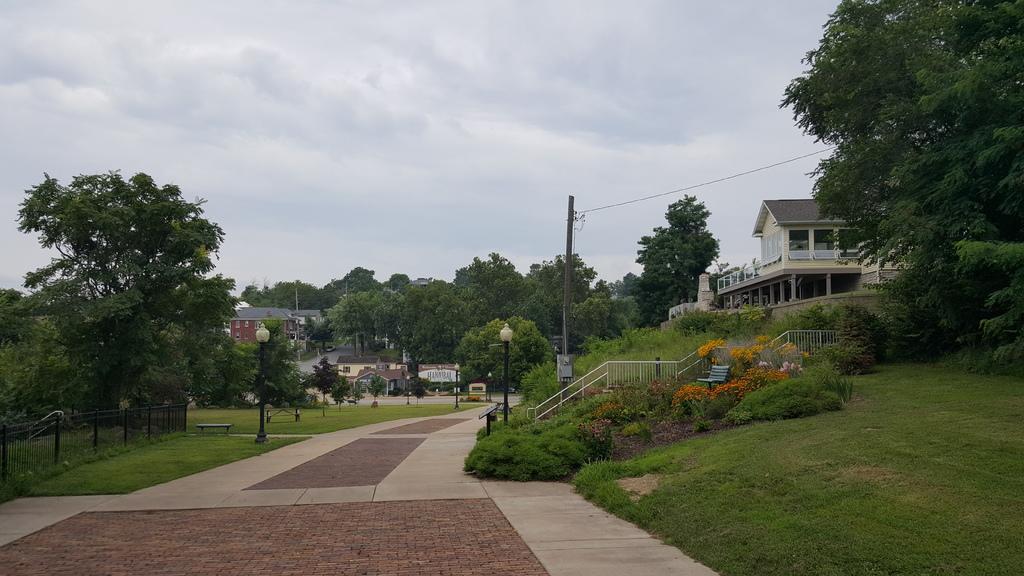How would you summarize this image in a sentence or two? In this image we can see houses, plants, trees, light poles, there are flowers, handrails, fencing, also we can see the sky. 